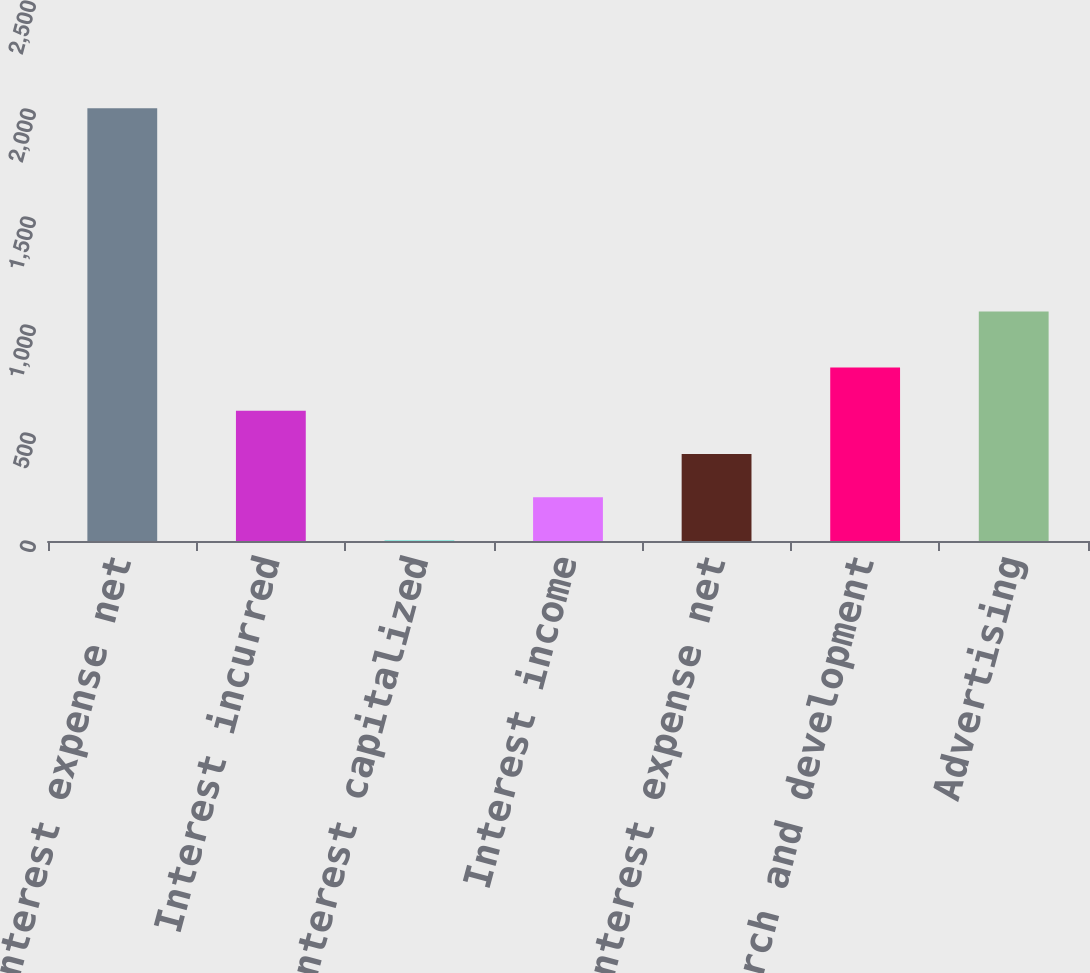Convert chart. <chart><loc_0><loc_0><loc_500><loc_500><bar_chart><fcel>Interest expense net<fcel>Interest incurred<fcel>Interest capitalized<fcel>Interest income<fcel>Total Interest expense net<fcel>Research and development<fcel>Advertising<nl><fcel>2004<fcel>602.81<fcel>2.3<fcel>202.47<fcel>402.64<fcel>802.98<fcel>1063<nl></chart> 